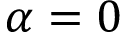<formula> <loc_0><loc_0><loc_500><loc_500>\alpha = 0</formula> 